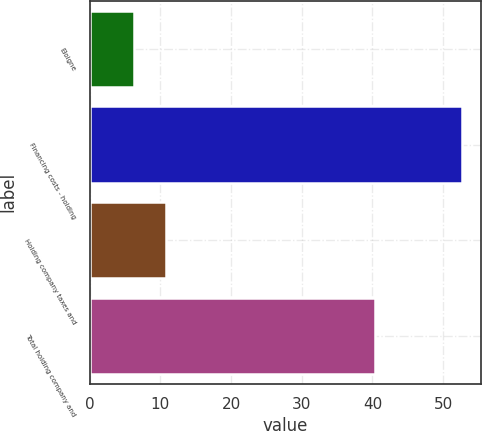Convert chart. <chart><loc_0><loc_0><loc_500><loc_500><bar_chart><fcel>Eloigne<fcel>Financing costs - holding<fcel>Holding company taxes and<fcel>Total holding company and<nl><fcel>6.2<fcel>52.7<fcel>10.85<fcel>40.3<nl></chart> 